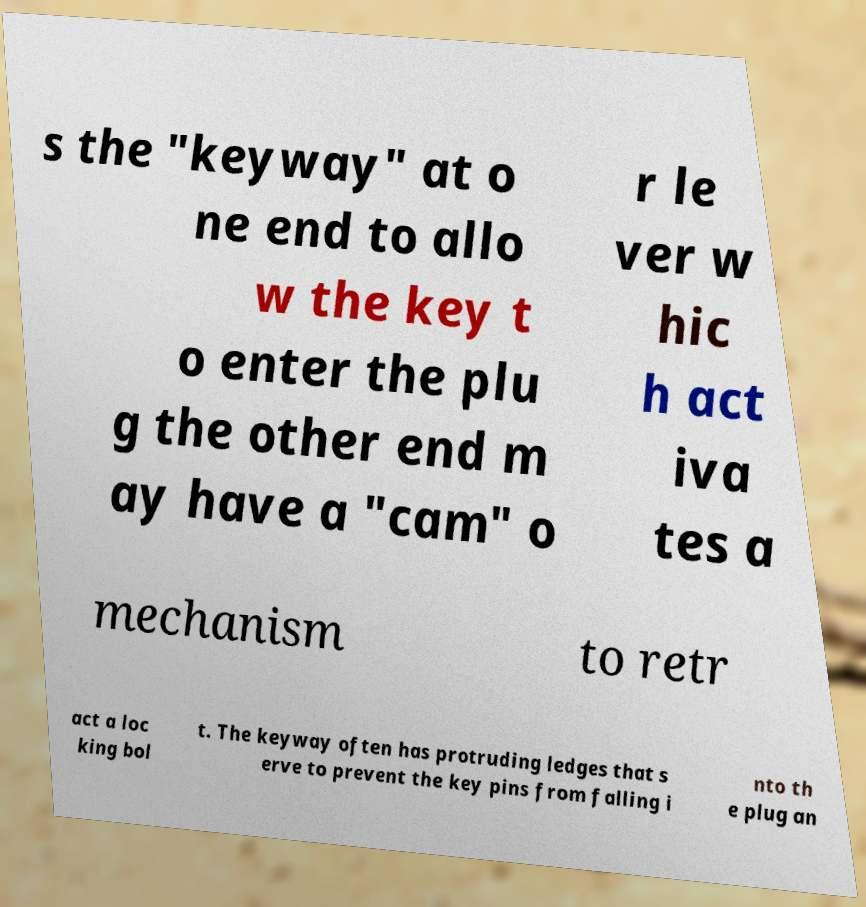Could you assist in decoding the text presented in this image and type it out clearly? s the "keyway" at o ne end to allo w the key t o enter the plu g the other end m ay have a "cam" o r le ver w hic h act iva tes a mechanism to retr act a loc king bol t. The keyway often has protruding ledges that s erve to prevent the key pins from falling i nto th e plug an 